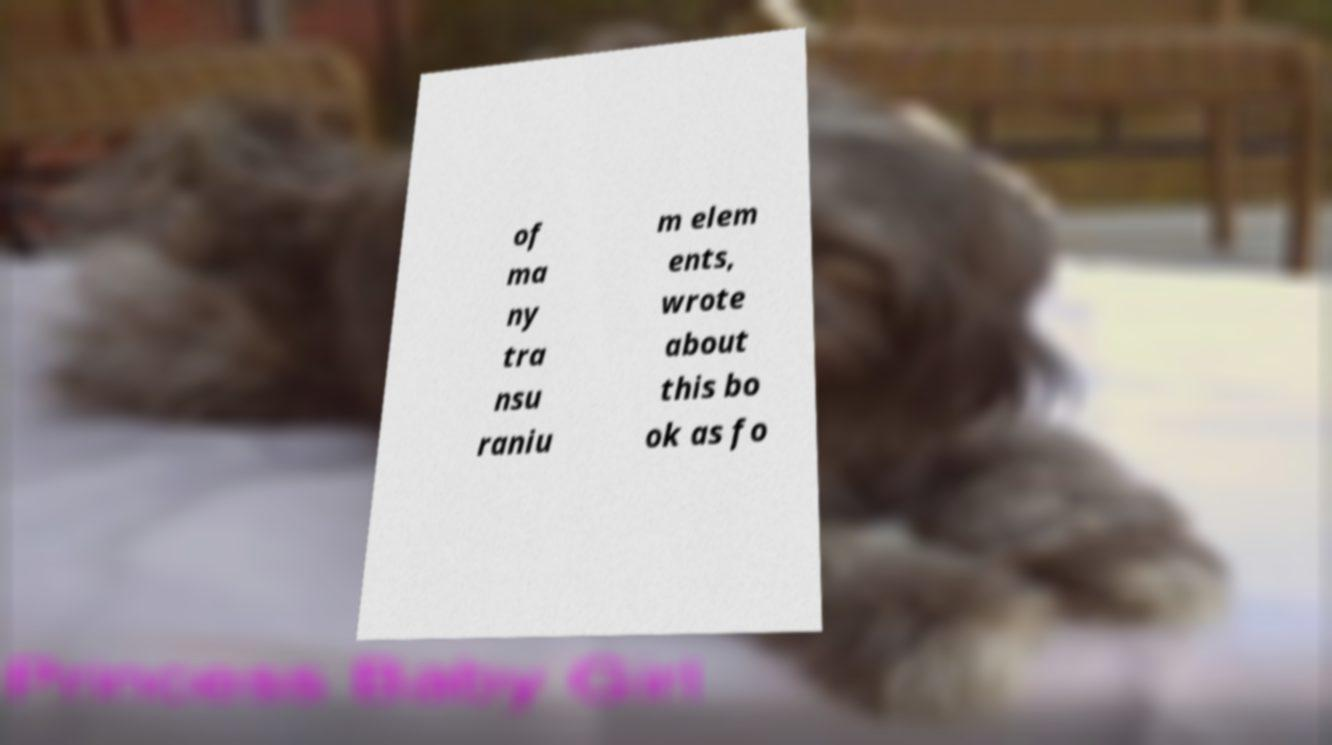Please identify and transcribe the text found in this image. of ma ny tra nsu raniu m elem ents, wrote about this bo ok as fo 